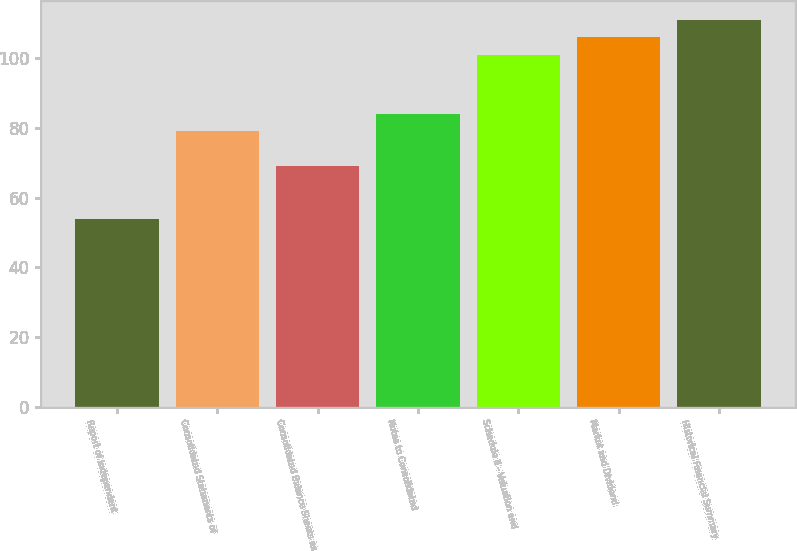Convert chart to OTSL. <chart><loc_0><loc_0><loc_500><loc_500><bar_chart><fcel>Report of Independent<fcel>Consolidated Statements of<fcel>Consolidated Balance Sheets as<fcel>Notes to Consolidated<fcel>Schedule II - Valuation and<fcel>Market and Dividend<fcel>Historical Financial Summary<nl><fcel>54<fcel>79<fcel>69<fcel>84<fcel>101<fcel>106<fcel>111<nl></chart> 